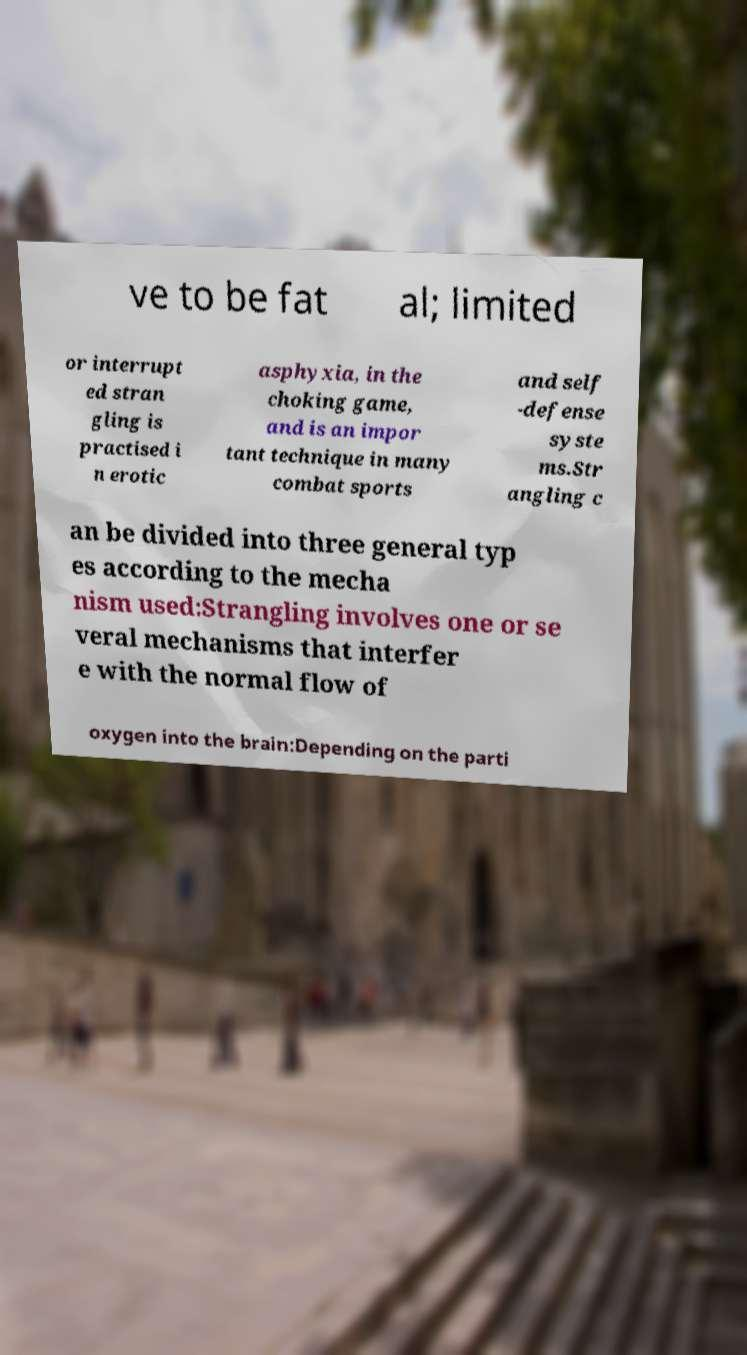I need the written content from this picture converted into text. Can you do that? ve to be fat al; limited or interrupt ed stran gling is practised i n erotic asphyxia, in the choking game, and is an impor tant technique in many combat sports and self -defense syste ms.Str angling c an be divided into three general typ es according to the mecha nism used:Strangling involves one or se veral mechanisms that interfer e with the normal flow of oxygen into the brain:Depending on the parti 